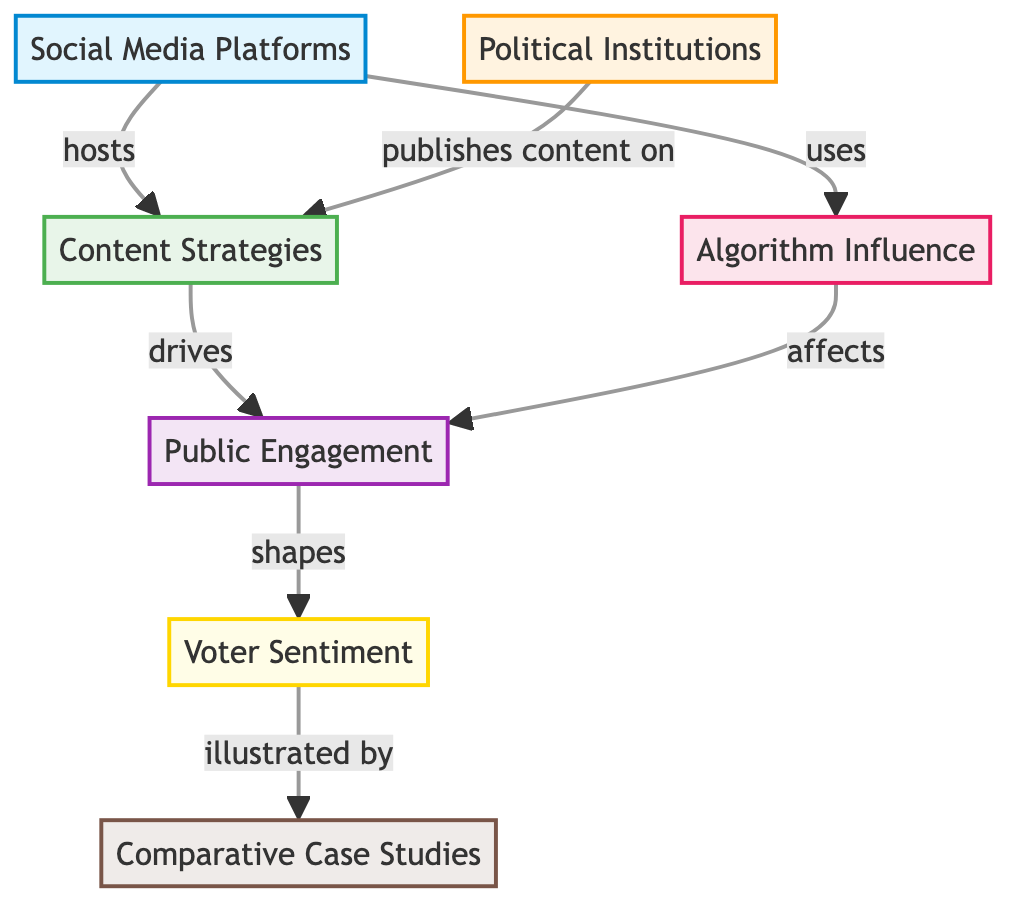What are the two main types of nodes in the diagram? The diagram consists of social media platforms and political institutions as two main types of nodes, representing the entities involved in influencing voter sentiments.
Answer: social media platforms, political institutions How many nodes are present in the diagram? Counting the nodes displayed, there are a total of seven nodes: social media platforms, political institutions, content strategies, public engagement, algorithm influence, voter sentiment, and comparative case studies.
Answer: seven Which node drives public engagement? The node marked "Content Strategies" is identified as the one that drives public engagement, showing the relationship between content creation and attracting the public's attention.
Answer: Content Strategies What does the algorithm influence affect? The "Algorithm Influence" node affects public engagement according to the diagram, indicating the role of algorithms in shaping how the public engages with content on social media platforms.
Answer: public engagement How many edges connect political institutions to other nodes? The diagram shows that there are two edges connecting the "Political Institutions" node to other nodes: one to "Content Strategies" and another indirectly to "Public Engagement" through content strategies.
Answer: two What is illustrated by the voter sentiment node? The "Voter Sentiment" node is illustrated by the "Comparative Case Studies," indicating that voter sentiments can be exemplified or demonstrated through specific case studies.
Answer: Comparative Case Studies What hosts the content strategies? "Social Media Platforms" is the node that hosts the content strategies, showing that these platforms provide the environment for content to be published and consumed.
Answer: Social Media Platforms Which node shapes voter sentiment? The "Public Engagement" node shapes voter sentiment, suggesting that how engaged the public is will influence their sentiments regarding political matters.
Answer: Public Engagement What is a consequence of the algorithm influence? The consequence of the algorithm influence, as shown in the diagram, is its effect on public engagement, emphasizing the role of algorithms in attracting or maintaining public interest.
Answer: public engagement 